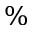Convert formula to latex. <formula><loc_0><loc_0><loc_500><loc_500>\%</formula> 